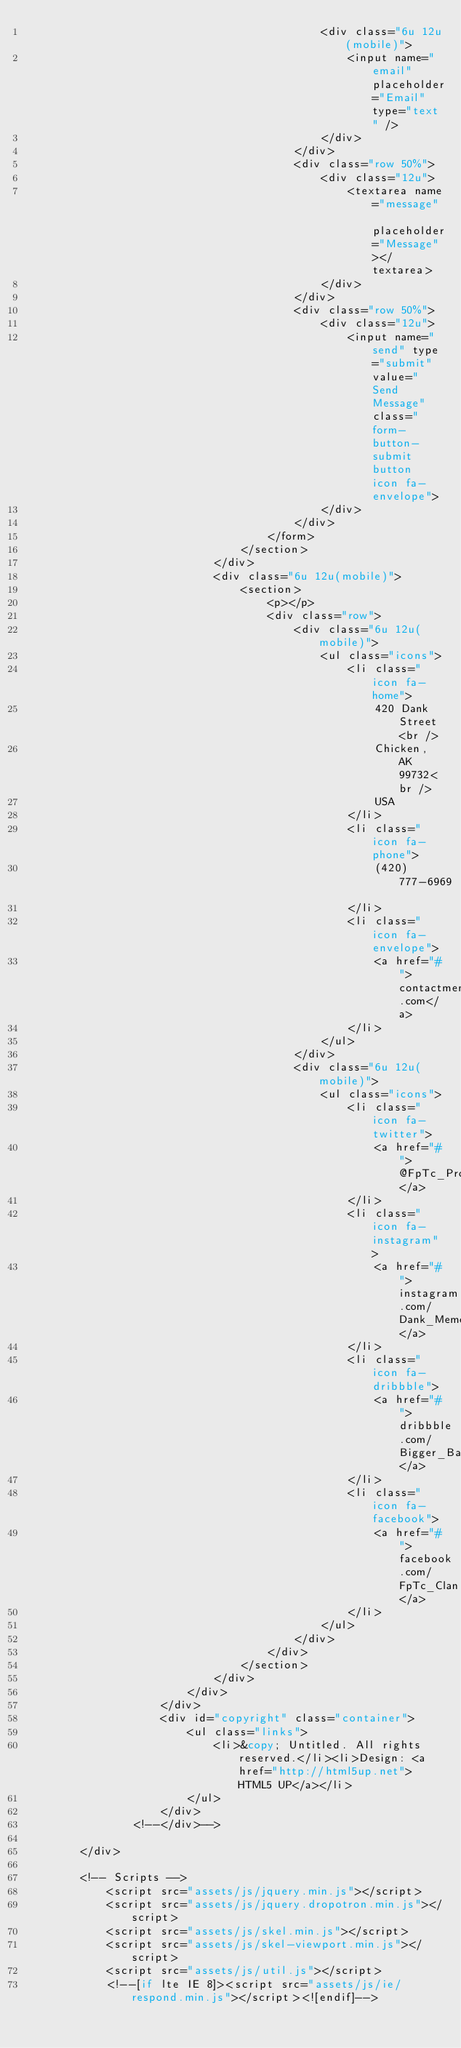<code> <loc_0><loc_0><loc_500><loc_500><_PHP_>											<div class="6u 12u(mobile)">
												<input name="email" placeholder="Email" type="text" />
											</div>
										</div>
										<div class="row 50%">
											<div class="12u">
												<textarea name="message" placeholder="Message"></textarea>
											</div>
										</div>
										<div class="row 50%">
											<div class="12u">
												<input name="send" type="submit" value="Send Message" class="form-button-submit button icon fa-envelope">
											</div>
										</div>
									</form>
								</section>
							</div>
							<div class="6u 12u(mobile)">
								<section>
									<p></p>
									<div class="row">
										<div class="6u 12u(mobile)">
											<ul class="icons">
												<li class="icon fa-home">
													420 Dank Street<br />
													Chicken, AK 99732<br />
													USA
												</li>
												<li class="icon fa-phone">
													(420) 777-6969
												</li>
												<li class="icon fa-envelope">
													<a href="#">contactmememarket@gmail.com</a>
												</li>
											</ul>
										</div>
										<div class="6u 12u(mobile)">
											<ul class="icons">
												<li class="icon fa-twitter">
													<a href="#">@FpTc_Productions</a>
												</li>
												<li class="icon fa-instagram">
													<a href="#">instagram.com/Dank_Memes_For_the_Soul</a>
												</li>
												<li class="icon fa-dribbble">
													<a href="#">dribbble.com/Bigger_Baller_Brand</a>
												</li>
												<li class="icon fa-facebook">
													<a href="#">facebook.com/FpTc_Clan</a>
												</li>
											</ul>
										</div>
									</div>
								</section>
							</div>
						</div>
					</div>
					<div id="copyright" class="container">
						<ul class="links">
							<li>&copy; Untitled. All rights reserved.</li><li>Design: <a href="http://html5up.net">HTML5 UP</a></li>
						</ul>
					</div>
				<!--</div>-->

		</div>

		<!-- Scripts -->
			<script src="assets/js/jquery.min.js"></script>
			<script src="assets/js/jquery.dropotron.min.js"></script>
			<script src="assets/js/skel.min.js"></script>
			<script src="assets/js/skel-viewport.min.js"></script>
			<script src="assets/js/util.js"></script>
			<!--[if lte IE 8]><script src="assets/js/ie/respond.min.js"></script><![endif]--></code> 